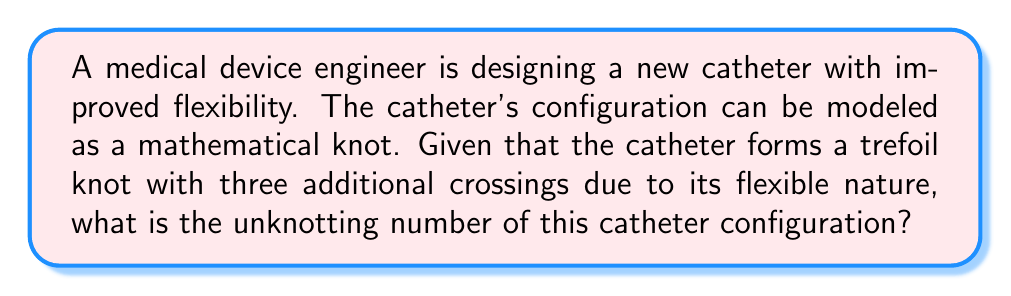Provide a solution to this math problem. To solve this problem, we need to follow these steps:

1. Understand the given information:
   - The catheter forms a trefoil knot
   - There are three additional crossings

2. Recall the unknotting number of a trefoil knot:
   - The unknotting number of a trefoil knot is 1

3. Analyze the additional crossings:
   - Each additional crossing can potentially increase the unknotting number by 1
   - However, not all crossings necessarily contribute to the unknotting number

4. Consider the worst-case scenario:
   - In the worst case, each additional crossing would require one more unknotting operation
   - Maximum potential unknotting number = Trefoil unknotting number + Additional crossings
   - $1 + 3 = 4$

5. Apply the principle of minimal crossing changes:
   - The unknotting number is defined as the minimum number of crossing changes needed
   - Some of the additional crossings might be resolved simultaneously or might not affect the unknotting process

6. Determine the range of possible unknotting numbers:
   - Minimum: The unknotting number of the original trefoil knot (1)
   - Maximum: The sum of the trefoil unknotting number and all additional crossings (4)

7. Conclude:
   - Without more specific information about the exact configuration, we can state that the unknotting number is at least 1 (from the trefoil) and at most 4 (if all additional crossings contribute)
   - The precise unknotting number would require detailed analysis of the specific crossing pattern

Therefore, the unknotting number of this catheter configuration is in the range $[1, 4]$, with 1 being the lower bound and 4 being the upper bound.
Answer: $1 \leq u \leq 4$, where $u$ is the unknotting number 